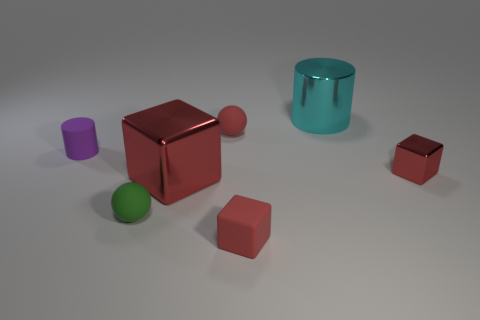Add 2 small red things. How many objects exist? 9 Subtract all blocks. How many objects are left? 4 Add 7 small red cubes. How many small red cubes exist? 9 Subtract 0 cyan cubes. How many objects are left? 7 Subtract all blue matte things. Subtract all tiny matte objects. How many objects are left? 3 Add 4 large red things. How many large red things are left? 5 